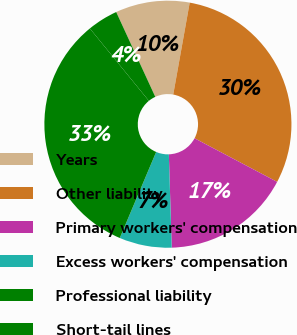Convert chart to OTSL. <chart><loc_0><loc_0><loc_500><loc_500><pie_chart><fcel>Years<fcel>Other liability<fcel>Primary workers' compensation<fcel>Excess workers' compensation<fcel>Professional liability<fcel>Short-tail lines<nl><fcel>9.7%<fcel>29.91%<fcel>16.78%<fcel>6.86%<fcel>32.75%<fcel>4.01%<nl></chart> 